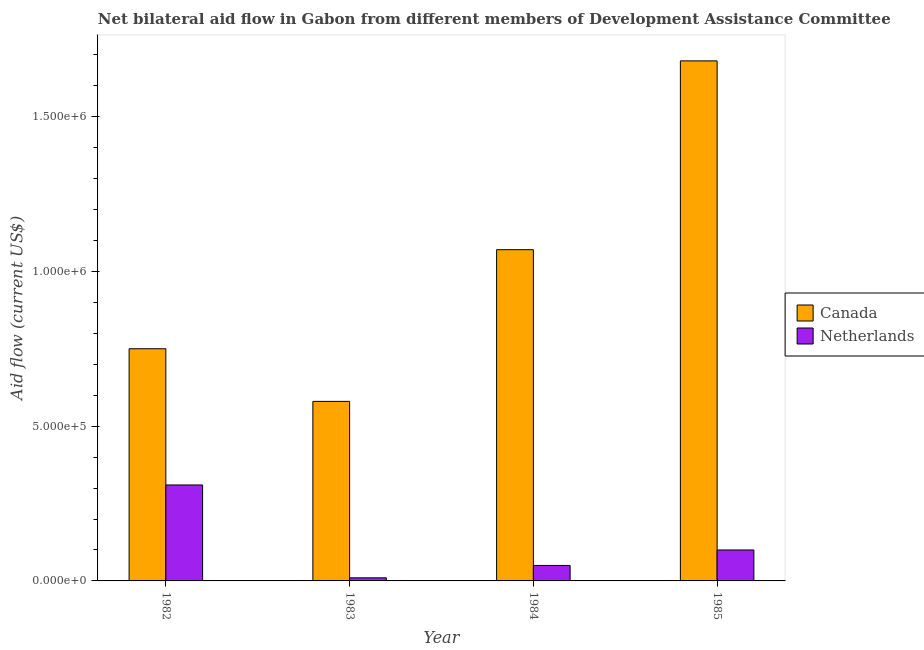How many groups of bars are there?
Keep it short and to the point. 4. Are the number of bars on each tick of the X-axis equal?
Your answer should be very brief. Yes. How many bars are there on the 3rd tick from the right?
Give a very brief answer. 2. In how many cases, is the number of bars for a given year not equal to the number of legend labels?
Give a very brief answer. 0. What is the amount of aid given by canada in 1984?
Ensure brevity in your answer.  1.07e+06. Across all years, what is the maximum amount of aid given by canada?
Keep it short and to the point. 1.68e+06. Across all years, what is the minimum amount of aid given by netherlands?
Provide a short and direct response. 10000. In which year was the amount of aid given by canada maximum?
Offer a terse response. 1985. What is the total amount of aid given by canada in the graph?
Your answer should be very brief. 4.08e+06. What is the difference between the amount of aid given by canada in 1982 and that in 1984?
Your answer should be compact. -3.20e+05. What is the difference between the amount of aid given by canada in 1982 and the amount of aid given by netherlands in 1985?
Provide a succinct answer. -9.30e+05. What is the average amount of aid given by canada per year?
Offer a terse response. 1.02e+06. In how many years, is the amount of aid given by canada greater than 1400000 US$?
Provide a short and direct response. 1. What is the ratio of the amount of aid given by netherlands in 1982 to that in 1983?
Provide a short and direct response. 31. Is the difference between the amount of aid given by canada in 1982 and 1984 greater than the difference between the amount of aid given by netherlands in 1982 and 1984?
Your answer should be compact. No. What is the difference between the highest and the second highest amount of aid given by canada?
Provide a succinct answer. 6.10e+05. What is the difference between the highest and the lowest amount of aid given by netherlands?
Offer a very short reply. 3.00e+05. In how many years, is the amount of aid given by netherlands greater than the average amount of aid given by netherlands taken over all years?
Provide a succinct answer. 1. What does the 1st bar from the left in 1985 represents?
Give a very brief answer. Canada. What does the 2nd bar from the right in 1983 represents?
Provide a succinct answer. Canada. What is the difference between two consecutive major ticks on the Y-axis?
Provide a succinct answer. 5.00e+05. How many legend labels are there?
Give a very brief answer. 2. How are the legend labels stacked?
Your answer should be compact. Vertical. What is the title of the graph?
Provide a succinct answer. Net bilateral aid flow in Gabon from different members of Development Assistance Committee. Does "Unregistered firms" appear as one of the legend labels in the graph?
Your answer should be compact. No. What is the Aid flow (current US$) of Canada in 1982?
Offer a very short reply. 7.50e+05. What is the Aid flow (current US$) in Canada in 1983?
Provide a succinct answer. 5.80e+05. What is the Aid flow (current US$) of Netherlands in 1983?
Provide a short and direct response. 10000. What is the Aid flow (current US$) in Canada in 1984?
Make the answer very short. 1.07e+06. What is the Aid flow (current US$) of Netherlands in 1984?
Give a very brief answer. 5.00e+04. What is the Aid flow (current US$) in Canada in 1985?
Your answer should be very brief. 1.68e+06. What is the Aid flow (current US$) of Netherlands in 1985?
Ensure brevity in your answer.  1.00e+05. Across all years, what is the maximum Aid flow (current US$) of Canada?
Offer a very short reply. 1.68e+06. Across all years, what is the maximum Aid flow (current US$) in Netherlands?
Offer a very short reply. 3.10e+05. Across all years, what is the minimum Aid flow (current US$) in Canada?
Your answer should be compact. 5.80e+05. Across all years, what is the minimum Aid flow (current US$) in Netherlands?
Provide a succinct answer. 10000. What is the total Aid flow (current US$) in Canada in the graph?
Offer a very short reply. 4.08e+06. What is the total Aid flow (current US$) of Netherlands in the graph?
Your answer should be compact. 4.70e+05. What is the difference between the Aid flow (current US$) in Canada in 1982 and that in 1983?
Your answer should be very brief. 1.70e+05. What is the difference between the Aid flow (current US$) in Netherlands in 1982 and that in 1983?
Offer a terse response. 3.00e+05. What is the difference between the Aid flow (current US$) in Canada in 1982 and that in 1984?
Provide a short and direct response. -3.20e+05. What is the difference between the Aid flow (current US$) of Canada in 1982 and that in 1985?
Offer a terse response. -9.30e+05. What is the difference between the Aid flow (current US$) of Netherlands in 1982 and that in 1985?
Offer a very short reply. 2.10e+05. What is the difference between the Aid flow (current US$) in Canada in 1983 and that in 1984?
Your response must be concise. -4.90e+05. What is the difference between the Aid flow (current US$) of Canada in 1983 and that in 1985?
Provide a short and direct response. -1.10e+06. What is the difference between the Aid flow (current US$) in Canada in 1984 and that in 1985?
Keep it short and to the point. -6.10e+05. What is the difference between the Aid flow (current US$) in Canada in 1982 and the Aid flow (current US$) in Netherlands in 1983?
Your answer should be very brief. 7.40e+05. What is the difference between the Aid flow (current US$) of Canada in 1982 and the Aid flow (current US$) of Netherlands in 1985?
Provide a short and direct response. 6.50e+05. What is the difference between the Aid flow (current US$) of Canada in 1983 and the Aid flow (current US$) of Netherlands in 1984?
Make the answer very short. 5.30e+05. What is the difference between the Aid flow (current US$) of Canada in 1984 and the Aid flow (current US$) of Netherlands in 1985?
Ensure brevity in your answer.  9.70e+05. What is the average Aid flow (current US$) in Canada per year?
Your answer should be very brief. 1.02e+06. What is the average Aid flow (current US$) of Netherlands per year?
Provide a short and direct response. 1.18e+05. In the year 1982, what is the difference between the Aid flow (current US$) of Canada and Aid flow (current US$) of Netherlands?
Offer a terse response. 4.40e+05. In the year 1983, what is the difference between the Aid flow (current US$) of Canada and Aid flow (current US$) of Netherlands?
Offer a terse response. 5.70e+05. In the year 1984, what is the difference between the Aid flow (current US$) in Canada and Aid flow (current US$) in Netherlands?
Your response must be concise. 1.02e+06. In the year 1985, what is the difference between the Aid flow (current US$) of Canada and Aid flow (current US$) of Netherlands?
Provide a succinct answer. 1.58e+06. What is the ratio of the Aid flow (current US$) in Canada in 1982 to that in 1983?
Your answer should be very brief. 1.29. What is the ratio of the Aid flow (current US$) in Netherlands in 1982 to that in 1983?
Ensure brevity in your answer.  31. What is the ratio of the Aid flow (current US$) of Canada in 1982 to that in 1984?
Offer a terse response. 0.7. What is the ratio of the Aid flow (current US$) of Netherlands in 1982 to that in 1984?
Offer a very short reply. 6.2. What is the ratio of the Aid flow (current US$) in Canada in 1982 to that in 1985?
Offer a very short reply. 0.45. What is the ratio of the Aid flow (current US$) in Netherlands in 1982 to that in 1985?
Your answer should be very brief. 3.1. What is the ratio of the Aid flow (current US$) in Canada in 1983 to that in 1984?
Make the answer very short. 0.54. What is the ratio of the Aid flow (current US$) in Netherlands in 1983 to that in 1984?
Ensure brevity in your answer.  0.2. What is the ratio of the Aid flow (current US$) of Canada in 1983 to that in 1985?
Ensure brevity in your answer.  0.35. What is the ratio of the Aid flow (current US$) in Netherlands in 1983 to that in 1985?
Keep it short and to the point. 0.1. What is the ratio of the Aid flow (current US$) of Canada in 1984 to that in 1985?
Your answer should be compact. 0.64. What is the ratio of the Aid flow (current US$) in Netherlands in 1984 to that in 1985?
Provide a succinct answer. 0.5. What is the difference between the highest and the second highest Aid flow (current US$) of Netherlands?
Ensure brevity in your answer.  2.10e+05. What is the difference between the highest and the lowest Aid flow (current US$) of Canada?
Ensure brevity in your answer.  1.10e+06. 